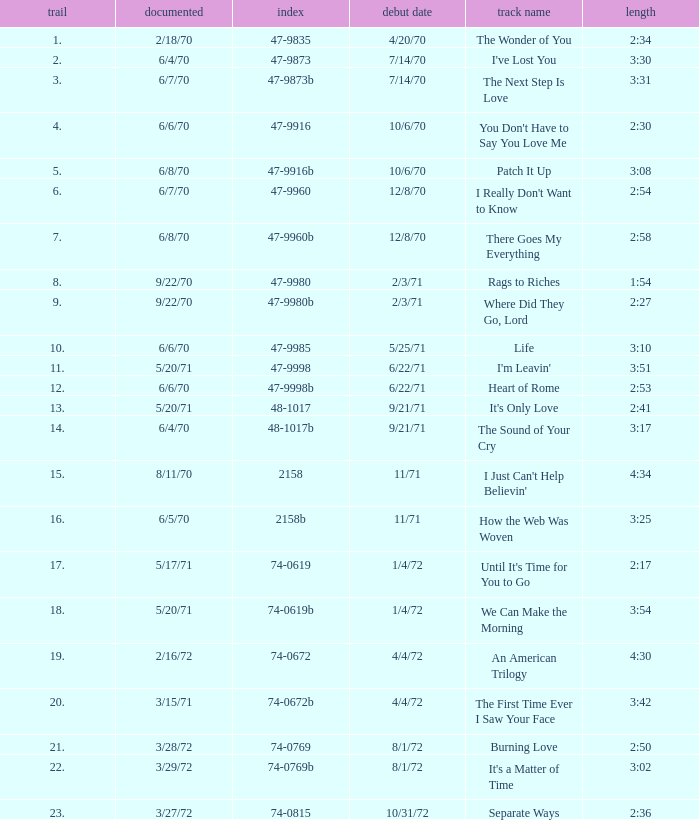What is the highest track for Burning Love? 21.0. 